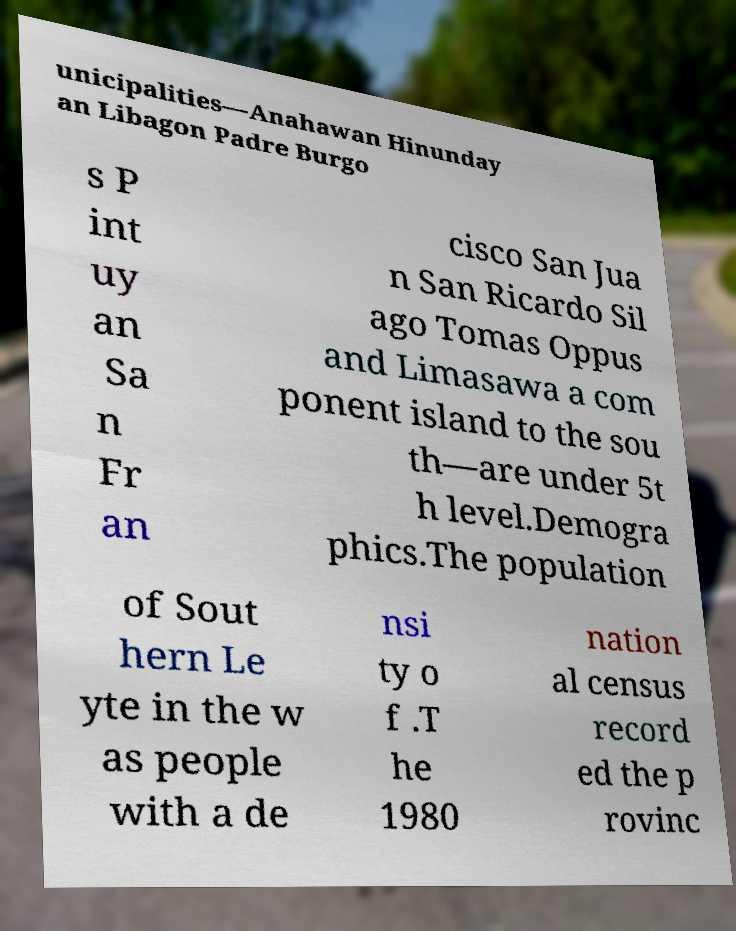Could you assist in decoding the text presented in this image and type it out clearly? unicipalities—Anahawan Hinunday an Libagon Padre Burgo s P int uy an Sa n Fr an cisco San Jua n San Ricardo Sil ago Tomas Oppus and Limasawa a com ponent island to the sou th—are under 5t h level.Demogra phics.The population of Sout hern Le yte in the w as people with a de nsi ty o f .T he 1980 nation al census record ed the p rovinc 